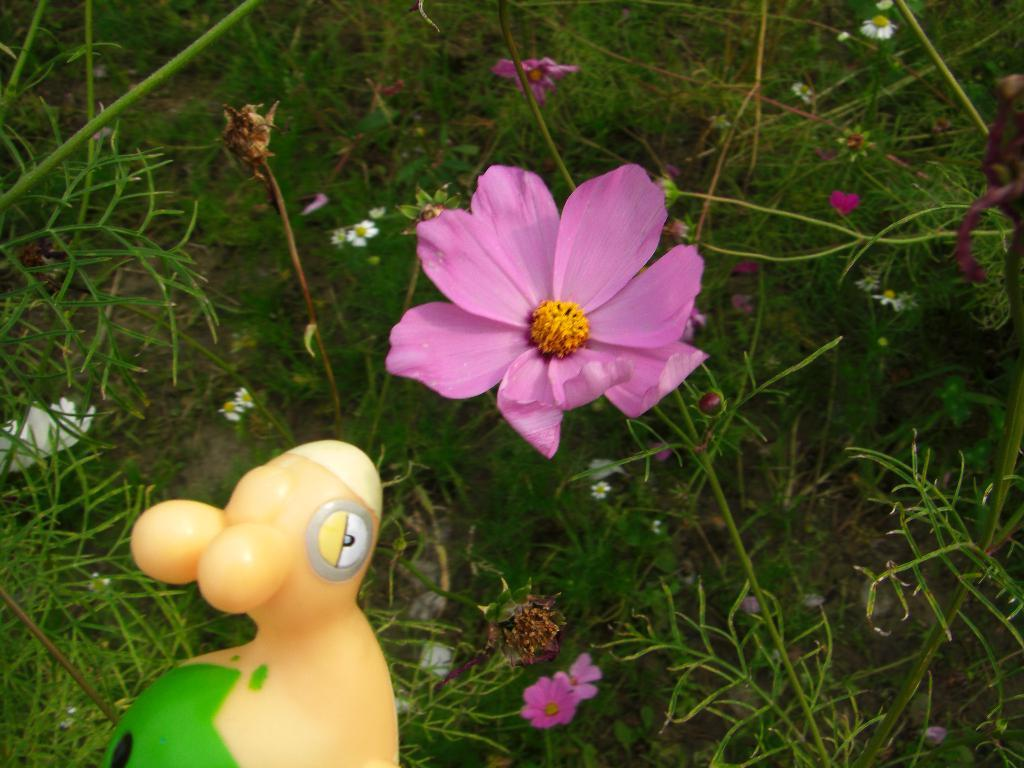What object in the image is typically associated with play or entertainment? There is a toy in the image. What types of vegetation can be seen in the image? There are different plants with different flowers in the image. What type of ground cover is present in the image? There is grass on the ground in the image. What type of nerve can be seen in the image? There are no nerves present in the image; it features a toy, plants with flowers, and grass. What is the purpose of the bucket in the image? There is no bucket present in the image. 